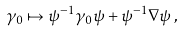Convert formula to latex. <formula><loc_0><loc_0><loc_500><loc_500>\gamma _ { 0 } \mapsto \psi ^ { - 1 } \gamma _ { 0 } \psi + \psi ^ { - 1 } { \nabla } \psi \, ,</formula> 